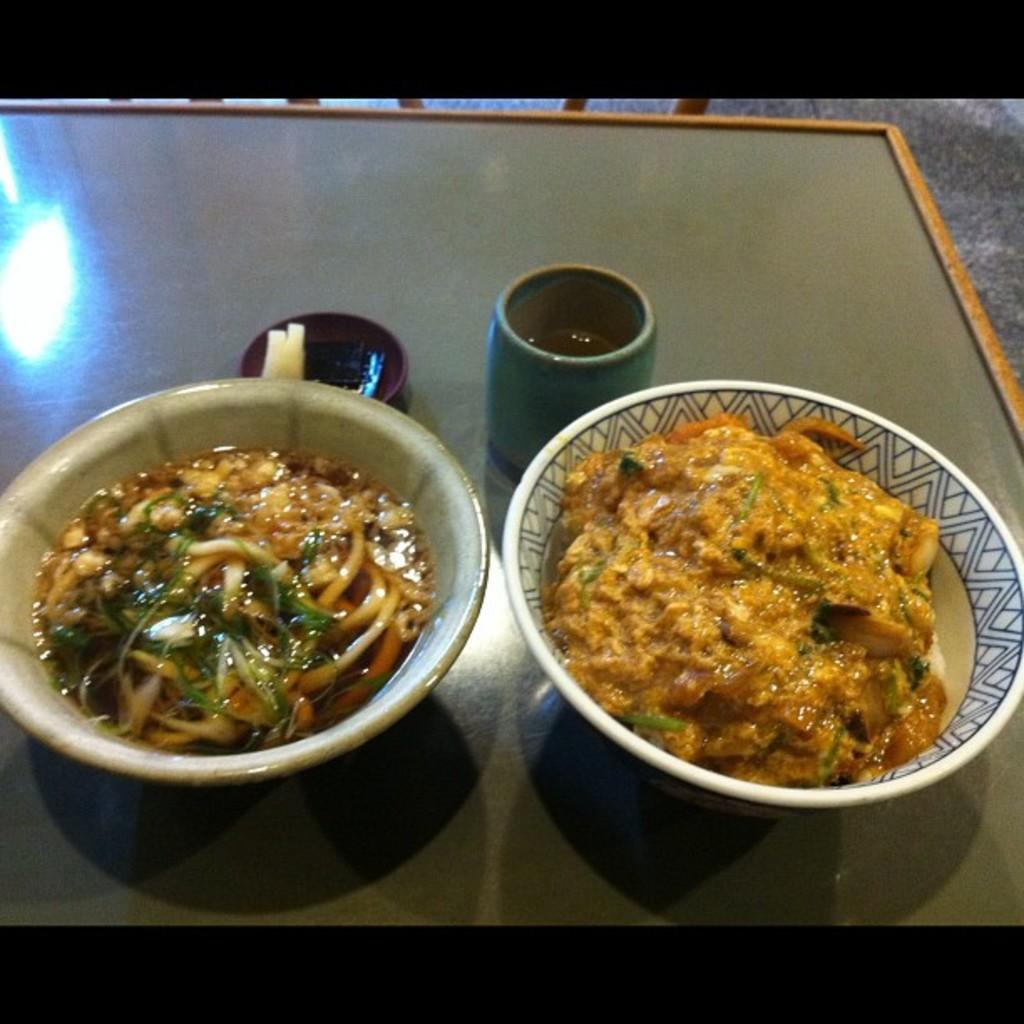What can be seen on the table in the image? There are two bowls of food items and a glass of drink on the table. Can you describe the food items in the bowls? The specific food items are not mentioned, but there are two bowls of food items on the table. What type of yoke can be seen attached to the lake in the image? There is no yoke or lake present in the image; it only features two bowls of food items and a glass of drink on a table. 